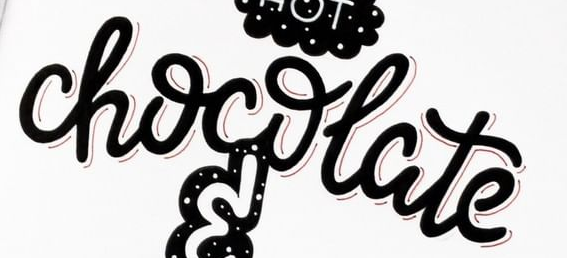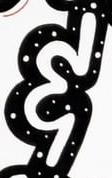What words are shown in these images in order, separated by a semicolon? chocolate; & 